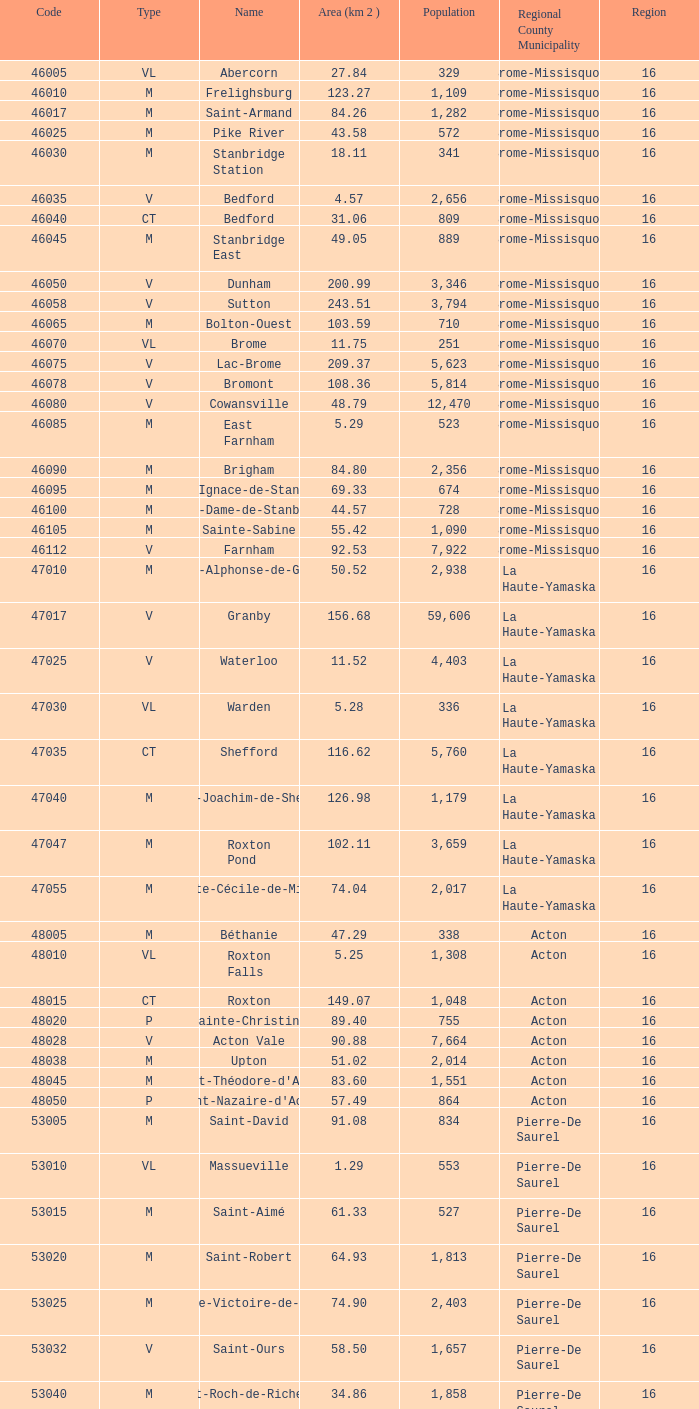Saint-blaise-sur-richelieu is less than 6 None. 